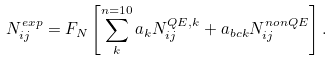Convert formula to latex. <formula><loc_0><loc_0><loc_500><loc_500>N _ { i j } ^ { e x p } = F _ { N } \left [ \sum _ { k } ^ { n = 1 0 } a _ { k } N ^ { Q E , k } _ { i j } + a _ { b c k } N ^ { n o n Q E } _ { i j } \right ] .</formula> 